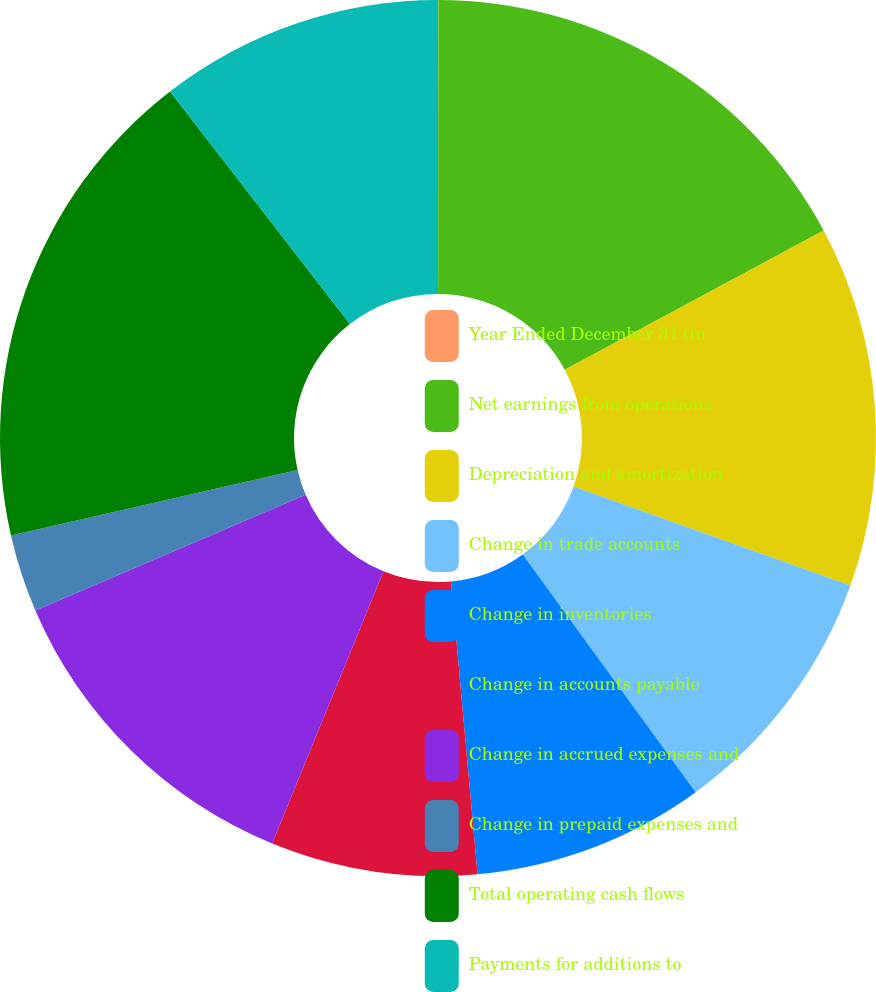<chart> <loc_0><loc_0><loc_500><loc_500><pie_chart><fcel>Year Ended December 31 (in<fcel>Net earnings from operations<fcel>Depreciation and amortization<fcel>Change in trade accounts<fcel>Change in inventories<fcel>Change in accounts payable<fcel>Change in accrued expenses and<fcel>Change in prepaid expenses and<fcel>Total operating cash flows<fcel>Payments for additions to<nl><fcel>0.01%<fcel>17.13%<fcel>13.33%<fcel>9.52%<fcel>8.57%<fcel>7.62%<fcel>12.38%<fcel>2.87%<fcel>18.09%<fcel>10.48%<nl></chart> 